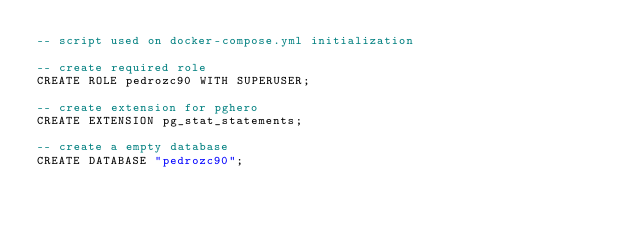Convert code to text. <code><loc_0><loc_0><loc_500><loc_500><_SQL_>-- script used on docker-compose.yml initialization

-- create required role
CREATE ROLE pedrozc90 WITH SUPERUSER;

-- create extension for pghero
CREATE EXTENSION pg_stat_statements;

-- create a empty database
CREATE DATABASE "pedrozc90";
</code> 